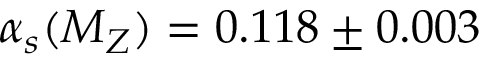<formula> <loc_0><loc_0><loc_500><loc_500>\alpha _ { s } ( M _ { Z } ) = 0 . 1 1 8 \pm 0 . 0 0 3</formula> 